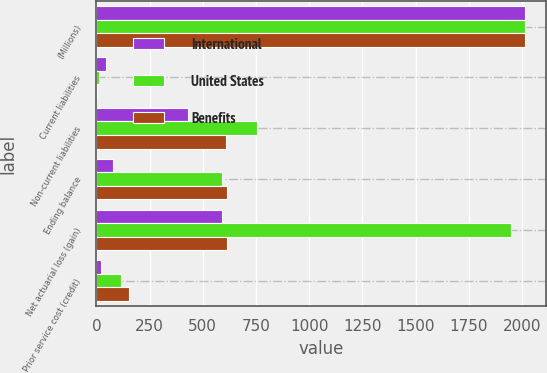<chart> <loc_0><loc_0><loc_500><loc_500><stacked_bar_chart><ecel><fcel>(Millions)<fcel>Current liabilities<fcel>Non-current liabilities<fcel>Ending balance<fcel>Net actuarial loss (gain)<fcel>Prior service cost (credit)<nl><fcel>International<fcel>2013<fcel>47<fcel>430<fcel>78<fcel>588<fcel>20<nl><fcel>United States<fcel>2013<fcel>10<fcel>756<fcel>588<fcel>1949<fcel>117<nl><fcel>Benefits<fcel>2013<fcel>4<fcel>608<fcel>612<fcel>616<fcel>151<nl></chart> 